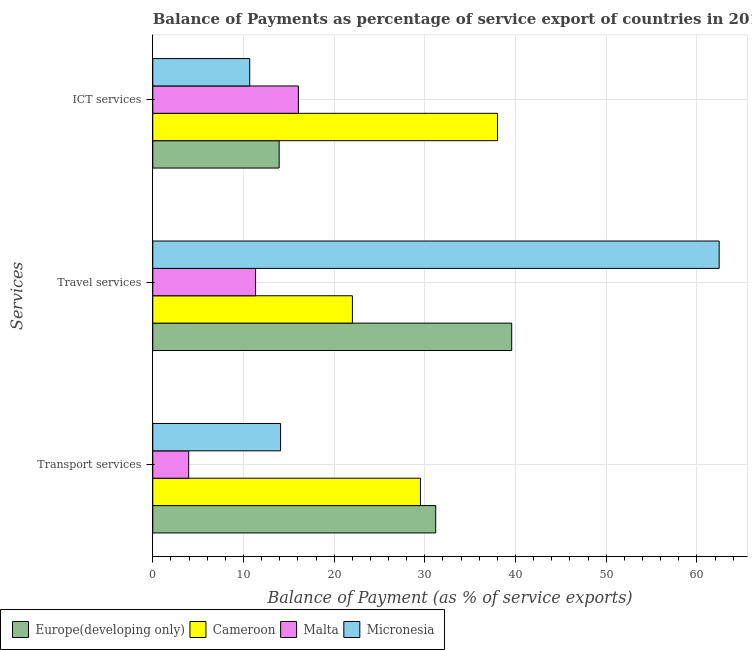How many different coloured bars are there?
Provide a short and direct response. 4. Are the number of bars per tick equal to the number of legend labels?
Offer a very short reply. Yes. Are the number of bars on each tick of the Y-axis equal?
Give a very brief answer. Yes. How many bars are there on the 3rd tick from the bottom?
Your response must be concise. 4. What is the label of the 2nd group of bars from the top?
Your answer should be compact. Travel services. What is the balance of payment of ict services in Cameroon?
Your answer should be compact. 38.01. Across all countries, what is the maximum balance of payment of ict services?
Your response must be concise. 38.01. Across all countries, what is the minimum balance of payment of ict services?
Make the answer very short. 10.69. In which country was the balance of payment of ict services maximum?
Your answer should be very brief. Cameroon. In which country was the balance of payment of ict services minimum?
Your response must be concise. Micronesia. What is the total balance of payment of travel services in the graph?
Offer a terse response. 135.39. What is the difference between the balance of payment of travel services in Malta and that in Cameroon?
Keep it short and to the point. -10.68. What is the difference between the balance of payment of transport services in Malta and the balance of payment of travel services in Cameroon?
Provide a short and direct response. -18.05. What is the average balance of payment of travel services per country?
Make the answer very short. 33.85. What is the difference between the balance of payment of travel services and balance of payment of ict services in Micronesia?
Give a very brief answer. 51.77. In how many countries, is the balance of payment of travel services greater than 38 %?
Give a very brief answer. 2. What is the ratio of the balance of payment of transport services in Europe(developing only) to that in Cameroon?
Give a very brief answer. 1.06. Is the balance of payment of transport services in Europe(developing only) less than that in Cameroon?
Give a very brief answer. No. Is the difference between the balance of payment of transport services in Malta and Micronesia greater than the difference between the balance of payment of travel services in Malta and Micronesia?
Provide a succinct answer. Yes. What is the difference between the highest and the second highest balance of payment of ict services?
Make the answer very short. 21.96. What is the difference between the highest and the lowest balance of payment of travel services?
Your answer should be very brief. 51.12. In how many countries, is the balance of payment of transport services greater than the average balance of payment of transport services taken over all countries?
Give a very brief answer. 2. What does the 3rd bar from the top in ICT services represents?
Your response must be concise. Cameroon. What does the 4th bar from the bottom in ICT services represents?
Offer a terse response. Micronesia. How many bars are there?
Keep it short and to the point. 12. Are all the bars in the graph horizontal?
Provide a short and direct response. Yes. How many countries are there in the graph?
Your answer should be very brief. 4. What is the difference between two consecutive major ticks on the X-axis?
Your response must be concise. 10. Does the graph contain any zero values?
Offer a very short reply. No. Where does the legend appear in the graph?
Offer a very short reply. Bottom left. How many legend labels are there?
Offer a terse response. 4. What is the title of the graph?
Offer a terse response. Balance of Payments as percentage of service export of countries in 2011. What is the label or title of the X-axis?
Ensure brevity in your answer.  Balance of Payment (as % of service exports). What is the label or title of the Y-axis?
Provide a short and direct response. Services. What is the Balance of Payment (as % of service exports) of Europe(developing only) in Transport services?
Give a very brief answer. 31.2. What is the Balance of Payment (as % of service exports) in Cameroon in Transport services?
Give a very brief answer. 29.52. What is the Balance of Payment (as % of service exports) in Malta in Transport services?
Give a very brief answer. 3.96. What is the Balance of Payment (as % of service exports) in Micronesia in Transport services?
Offer a very short reply. 14.09. What is the Balance of Payment (as % of service exports) of Europe(developing only) in Travel services?
Your answer should be compact. 39.58. What is the Balance of Payment (as % of service exports) in Cameroon in Travel services?
Offer a terse response. 22.01. What is the Balance of Payment (as % of service exports) in Malta in Travel services?
Your answer should be compact. 11.34. What is the Balance of Payment (as % of service exports) of Micronesia in Travel services?
Your answer should be compact. 62.46. What is the Balance of Payment (as % of service exports) in Europe(developing only) in ICT services?
Provide a short and direct response. 13.94. What is the Balance of Payment (as % of service exports) in Cameroon in ICT services?
Offer a terse response. 38.01. What is the Balance of Payment (as % of service exports) in Malta in ICT services?
Ensure brevity in your answer.  16.06. What is the Balance of Payment (as % of service exports) of Micronesia in ICT services?
Offer a terse response. 10.69. Across all Services, what is the maximum Balance of Payment (as % of service exports) of Europe(developing only)?
Make the answer very short. 39.58. Across all Services, what is the maximum Balance of Payment (as % of service exports) of Cameroon?
Keep it short and to the point. 38.01. Across all Services, what is the maximum Balance of Payment (as % of service exports) in Malta?
Keep it short and to the point. 16.06. Across all Services, what is the maximum Balance of Payment (as % of service exports) in Micronesia?
Keep it short and to the point. 62.46. Across all Services, what is the minimum Balance of Payment (as % of service exports) in Europe(developing only)?
Provide a short and direct response. 13.94. Across all Services, what is the minimum Balance of Payment (as % of service exports) of Cameroon?
Provide a succinct answer. 22.01. Across all Services, what is the minimum Balance of Payment (as % of service exports) in Malta?
Offer a very short reply. 3.96. Across all Services, what is the minimum Balance of Payment (as % of service exports) in Micronesia?
Provide a succinct answer. 10.69. What is the total Balance of Payment (as % of service exports) in Europe(developing only) in the graph?
Provide a succinct answer. 84.72. What is the total Balance of Payment (as % of service exports) in Cameroon in the graph?
Your answer should be very brief. 89.55. What is the total Balance of Payment (as % of service exports) in Malta in the graph?
Give a very brief answer. 31.35. What is the total Balance of Payment (as % of service exports) in Micronesia in the graph?
Provide a short and direct response. 87.24. What is the difference between the Balance of Payment (as % of service exports) of Europe(developing only) in Transport services and that in Travel services?
Your response must be concise. -8.38. What is the difference between the Balance of Payment (as % of service exports) in Cameroon in Transport services and that in Travel services?
Make the answer very short. 7.5. What is the difference between the Balance of Payment (as % of service exports) of Malta in Transport services and that in Travel services?
Give a very brief answer. -7.38. What is the difference between the Balance of Payment (as % of service exports) of Micronesia in Transport services and that in Travel services?
Offer a terse response. -48.36. What is the difference between the Balance of Payment (as % of service exports) of Europe(developing only) in Transport services and that in ICT services?
Keep it short and to the point. 17.26. What is the difference between the Balance of Payment (as % of service exports) in Cameroon in Transport services and that in ICT services?
Your answer should be compact. -8.5. What is the difference between the Balance of Payment (as % of service exports) of Malta in Transport services and that in ICT services?
Provide a short and direct response. -12.1. What is the difference between the Balance of Payment (as % of service exports) in Micronesia in Transport services and that in ICT services?
Provide a short and direct response. 3.4. What is the difference between the Balance of Payment (as % of service exports) in Europe(developing only) in Travel services and that in ICT services?
Give a very brief answer. 25.64. What is the difference between the Balance of Payment (as % of service exports) in Cameroon in Travel services and that in ICT services?
Ensure brevity in your answer.  -16. What is the difference between the Balance of Payment (as % of service exports) of Malta in Travel services and that in ICT services?
Your answer should be compact. -4.72. What is the difference between the Balance of Payment (as % of service exports) in Micronesia in Travel services and that in ICT services?
Your answer should be compact. 51.77. What is the difference between the Balance of Payment (as % of service exports) of Europe(developing only) in Transport services and the Balance of Payment (as % of service exports) of Cameroon in Travel services?
Offer a terse response. 9.19. What is the difference between the Balance of Payment (as % of service exports) of Europe(developing only) in Transport services and the Balance of Payment (as % of service exports) of Malta in Travel services?
Provide a succinct answer. 19.86. What is the difference between the Balance of Payment (as % of service exports) of Europe(developing only) in Transport services and the Balance of Payment (as % of service exports) of Micronesia in Travel services?
Your response must be concise. -31.26. What is the difference between the Balance of Payment (as % of service exports) of Cameroon in Transport services and the Balance of Payment (as % of service exports) of Malta in Travel services?
Ensure brevity in your answer.  18.18. What is the difference between the Balance of Payment (as % of service exports) in Cameroon in Transport services and the Balance of Payment (as % of service exports) in Micronesia in Travel services?
Ensure brevity in your answer.  -32.94. What is the difference between the Balance of Payment (as % of service exports) in Malta in Transport services and the Balance of Payment (as % of service exports) in Micronesia in Travel services?
Your response must be concise. -58.5. What is the difference between the Balance of Payment (as % of service exports) in Europe(developing only) in Transport services and the Balance of Payment (as % of service exports) in Cameroon in ICT services?
Offer a terse response. -6.81. What is the difference between the Balance of Payment (as % of service exports) of Europe(developing only) in Transport services and the Balance of Payment (as % of service exports) of Malta in ICT services?
Offer a terse response. 15.14. What is the difference between the Balance of Payment (as % of service exports) in Europe(developing only) in Transport services and the Balance of Payment (as % of service exports) in Micronesia in ICT services?
Your response must be concise. 20.51. What is the difference between the Balance of Payment (as % of service exports) of Cameroon in Transport services and the Balance of Payment (as % of service exports) of Malta in ICT services?
Offer a terse response. 13.46. What is the difference between the Balance of Payment (as % of service exports) of Cameroon in Transport services and the Balance of Payment (as % of service exports) of Micronesia in ICT services?
Offer a very short reply. 18.83. What is the difference between the Balance of Payment (as % of service exports) in Malta in Transport services and the Balance of Payment (as % of service exports) in Micronesia in ICT services?
Offer a terse response. -6.73. What is the difference between the Balance of Payment (as % of service exports) of Europe(developing only) in Travel services and the Balance of Payment (as % of service exports) of Cameroon in ICT services?
Your response must be concise. 1.57. What is the difference between the Balance of Payment (as % of service exports) in Europe(developing only) in Travel services and the Balance of Payment (as % of service exports) in Malta in ICT services?
Keep it short and to the point. 23.53. What is the difference between the Balance of Payment (as % of service exports) in Europe(developing only) in Travel services and the Balance of Payment (as % of service exports) in Micronesia in ICT services?
Ensure brevity in your answer.  28.89. What is the difference between the Balance of Payment (as % of service exports) in Cameroon in Travel services and the Balance of Payment (as % of service exports) in Malta in ICT services?
Your answer should be compact. 5.96. What is the difference between the Balance of Payment (as % of service exports) in Cameroon in Travel services and the Balance of Payment (as % of service exports) in Micronesia in ICT services?
Offer a terse response. 11.32. What is the difference between the Balance of Payment (as % of service exports) of Malta in Travel services and the Balance of Payment (as % of service exports) of Micronesia in ICT services?
Your answer should be compact. 0.65. What is the average Balance of Payment (as % of service exports) of Europe(developing only) per Services?
Offer a terse response. 28.24. What is the average Balance of Payment (as % of service exports) of Cameroon per Services?
Give a very brief answer. 29.85. What is the average Balance of Payment (as % of service exports) of Malta per Services?
Ensure brevity in your answer.  10.45. What is the average Balance of Payment (as % of service exports) in Micronesia per Services?
Your response must be concise. 29.08. What is the difference between the Balance of Payment (as % of service exports) in Europe(developing only) and Balance of Payment (as % of service exports) in Cameroon in Transport services?
Offer a very short reply. 1.68. What is the difference between the Balance of Payment (as % of service exports) of Europe(developing only) and Balance of Payment (as % of service exports) of Malta in Transport services?
Offer a very short reply. 27.24. What is the difference between the Balance of Payment (as % of service exports) of Europe(developing only) and Balance of Payment (as % of service exports) of Micronesia in Transport services?
Make the answer very short. 17.11. What is the difference between the Balance of Payment (as % of service exports) in Cameroon and Balance of Payment (as % of service exports) in Malta in Transport services?
Provide a succinct answer. 25.56. What is the difference between the Balance of Payment (as % of service exports) of Cameroon and Balance of Payment (as % of service exports) of Micronesia in Transport services?
Offer a terse response. 15.42. What is the difference between the Balance of Payment (as % of service exports) in Malta and Balance of Payment (as % of service exports) in Micronesia in Transport services?
Provide a succinct answer. -10.13. What is the difference between the Balance of Payment (as % of service exports) in Europe(developing only) and Balance of Payment (as % of service exports) in Cameroon in Travel services?
Your answer should be very brief. 17.57. What is the difference between the Balance of Payment (as % of service exports) in Europe(developing only) and Balance of Payment (as % of service exports) in Malta in Travel services?
Provide a succinct answer. 28.24. What is the difference between the Balance of Payment (as % of service exports) in Europe(developing only) and Balance of Payment (as % of service exports) in Micronesia in Travel services?
Make the answer very short. -22.88. What is the difference between the Balance of Payment (as % of service exports) in Cameroon and Balance of Payment (as % of service exports) in Malta in Travel services?
Provide a short and direct response. 10.68. What is the difference between the Balance of Payment (as % of service exports) in Cameroon and Balance of Payment (as % of service exports) in Micronesia in Travel services?
Give a very brief answer. -40.44. What is the difference between the Balance of Payment (as % of service exports) in Malta and Balance of Payment (as % of service exports) in Micronesia in Travel services?
Give a very brief answer. -51.12. What is the difference between the Balance of Payment (as % of service exports) of Europe(developing only) and Balance of Payment (as % of service exports) of Cameroon in ICT services?
Offer a very short reply. -24.08. What is the difference between the Balance of Payment (as % of service exports) of Europe(developing only) and Balance of Payment (as % of service exports) of Malta in ICT services?
Keep it short and to the point. -2.12. What is the difference between the Balance of Payment (as % of service exports) in Europe(developing only) and Balance of Payment (as % of service exports) in Micronesia in ICT services?
Your response must be concise. 3.25. What is the difference between the Balance of Payment (as % of service exports) of Cameroon and Balance of Payment (as % of service exports) of Malta in ICT services?
Make the answer very short. 21.96. What is the difference between the Balance of Payment (as % of service exports) in Cameroon and Balance of Payment (as % of service exports) in Micronesia in ICT services?
Make the answer very short. 27.32. What is the difference between the Balance of Payment (as % of service exports) in Malta and Balance of Payment (as % of service exports) in Micronesia in ICT services?
Provide a short and direct response. 5.36. What is the ratio of the Balance of Payment (as % of service exports) in Europe(developing only) in Transport services to that in Travel services?
Offer a very short reply. 0.79. What is the ratio of the Balance of Payment (as % of service exports) in Cameroon in Transport services to that in Travel services?
Ensure brevity in your answer.  1.34. What is the ratio of the Balance of Payment (as % of service exports) in Malta in Transport services to that in Travel services?
Provide a succinct answer. 0.35. What is the ratio of the Balance of Payment (as % of service exports) of Micronesia in Transport services to that in Travel services?
Provide a succinct answer. 0.23. What is the ratio of the Balance of Payment (as % of service exports) in Europe(developing only) in Transport services to that in ICT services?
Offer a terse response. 2.24. What is the ratio of the Balance of Payment (as % of service exports) in Cameroon in Transport services to that in ICT services?
Offer a very short reply. 0.78. What is the ratio of the Balance of Payment (as % of service exports) of Malta in Transport services to that in ICT services?
Offer a terse response. 0.25. What is the ratio of the Balance of Payment (as % of service exports) in Micronesia in Transport services to that in ICT services?
Your answer should be compact. 1.32. What is the ratio of the Balance of Payment (as % of service exports) of Europe(developing only) in Travel services to that in ICT services?
Make the answer very short. 2.84. What is the ratio of the Balance of Payment (as % of service exports) of Cameroon in Travel services to that in ICT services?
Offer a very short reply. 0.58. What is the ratio of the Balance of Payment (as % of service exports) in Malta in Travel services to that in ICT services?
Offer a terse response. 0.71. What is the ratio of the Balance of Payment (as % of service exports) of Micronesia in Travel services to that in ICT services?
Your response must be concise. 5.84. What is the difference between the highest and the second highest Balance of Payment (as % of service exports) of Europe(developing only)?
Offer a very short reply. 8.38. What is the difference between the highest and the second highest Balance of Payment (as % of service exports) of Cameroon?
Ensure brevity in your answer.  8.5. What is the difference between the highest and the second highest Balance of Payment (as % of service exports) in Malta?
Offer a very short reply. 4.72. What is the difference between the highest and the second highest Balance of Payment (as % of service exports) of Micronesia?
Your answer should be compact. 48.36. What is the difference between the highest and the lowest Balance of Payment (as % of service exports) of Europe(developing only)?
Your response must be concise. 25.64. What is the difference between the highest and the lowest Balance of Payment (as % of service exports) in Cameroon?
Your response must be concise. 16. What is the difference between the highest and the lowest Balance of Payment (as % of service exports) of Malta?
Your answer should be compact. 12.1. What is the difference between the highest and the lowest Balance of Payment (as % of service exports) of Micronesia?
Offer a very short reply. 51.77. 